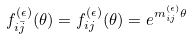<formula> <loc_0><loc_0><loc_500><loc_500>f _ { i \bar { j } } ^ { ( \epsilon ) } ( \theta ) = f _ { i j } ^ { ( \epsilon ) } ( \theta ) = e ^ { m _ { i j } ^ { ( \epsilon ) } \theta }</formula> 